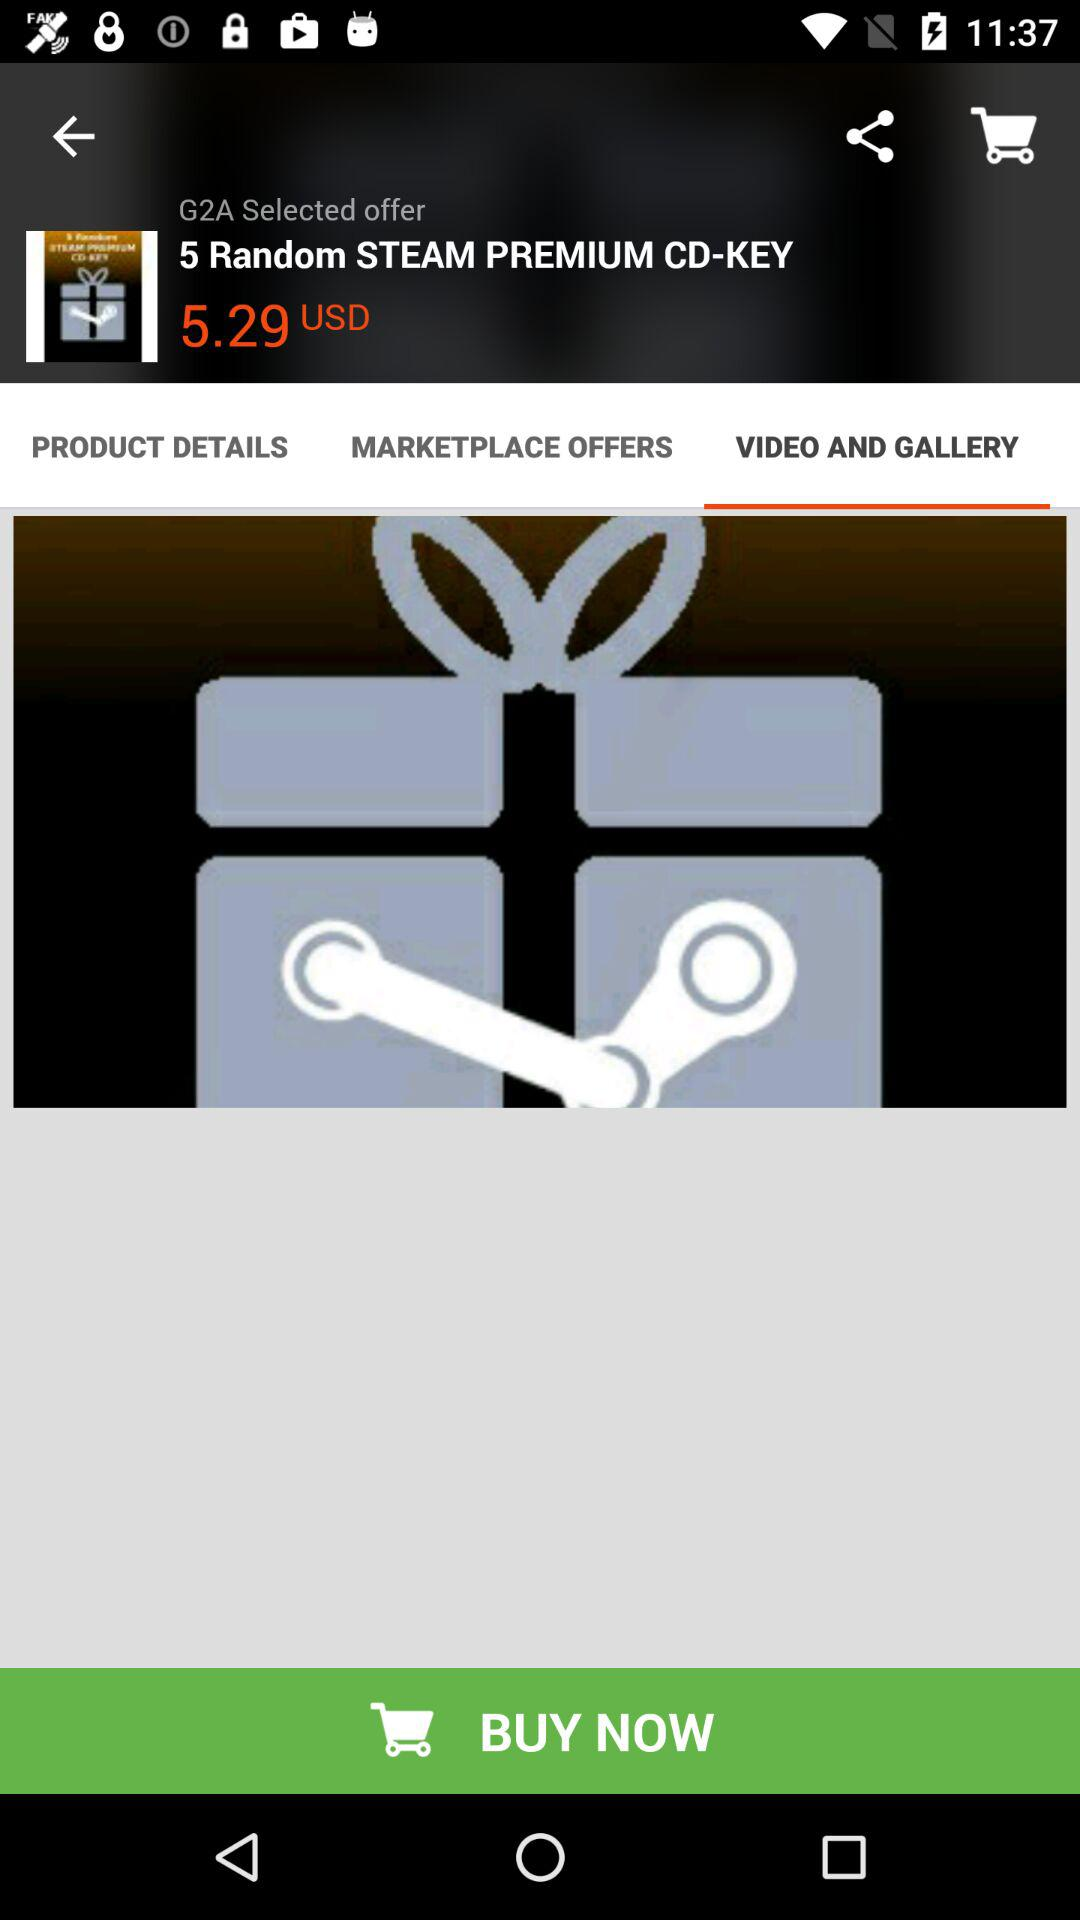How much is the price of the product in USD?
Answer the question using a single word or phrase. 5.29 